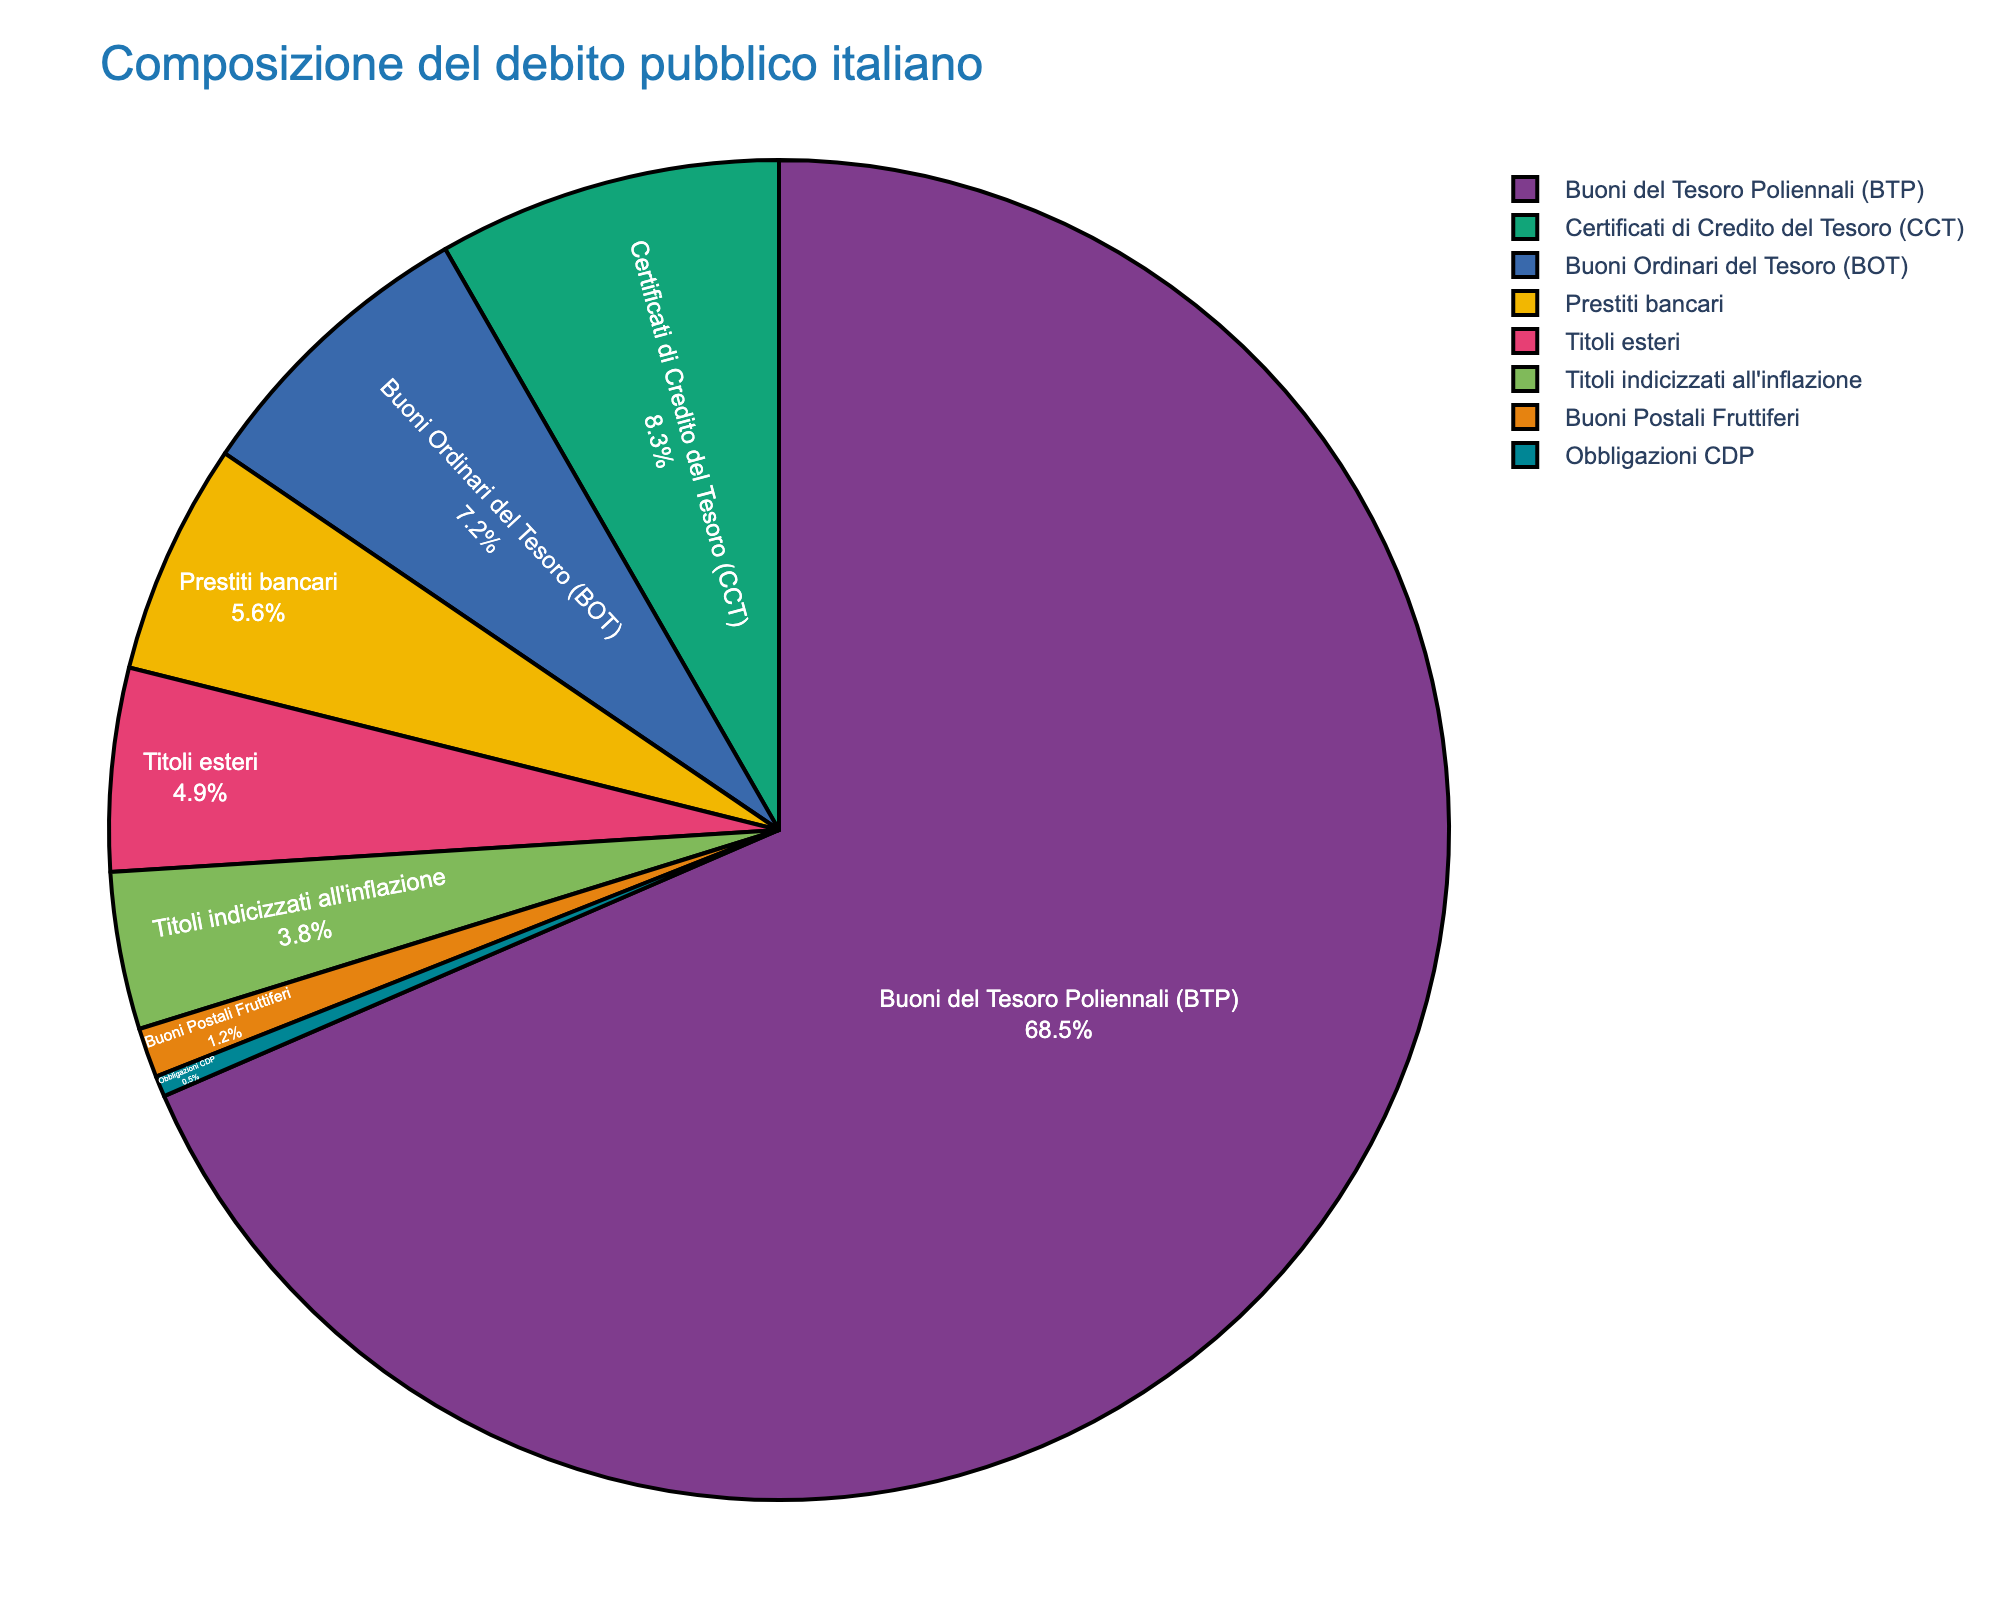What is the financial instrument that constitutes the largest percentage of the Italian public debt? The pie chart shows various financial instruments with their corresponding percentages. The largest section of the pie chart belongs to "Buoni del Tesoro Poliennali (BTP)" with 68.5%.
Answer: Buoni del Tesoro Poliennali (BTP) How much more percentage does Buoni del Tesoro Poliennali (BTP) have compared to Buoni Ordinari del Tesoro (BOT)? Buoni del Tesoro Poliennali (BTP) has 68.5%, while Buoni Ordinari del Tesoro (BOT) has 7.2%. The difference is calculated as 68.5% - 7.2% = 61.3%.
Answer: 61.3% What is the combined percentage of Certificati di Credito del Tesoro (CCT) and Prestiti bancari? The pie chart indicates Certificati di Credito del Tesoro (CCT) at 8.3% and Prestiti bancari at 5.6%. The sum is 8.3% + 5.6% = 13.9%.
Answer: 13.9% Which financial instruments have percentages that are less than 5%? The financial instruments with percentages less than 5% are Titoli esteri with 4.9%, Titoli indicizzati all'inflazione with 3.8%, Buoni Postali Fruttiferi with 1.2%, and Obbligazioni CDP with 0.5%.
Answer: Titoli esteri, Titoli indicizzati all'inflazione, Buoni Postali Fruttiferi, Obbligazioni CDP What is the average percentage of Buoni Ordinari del Tesoro (BOT), Certificati di Credito del Tesoro (CCT), and Prestiti bancari? The percentages for Buoni Ordinari del Tesoro (BOT), Certificati di Credito del Tesoro (CCT), and Prestiti bancari are 7.2%, 8.3%, and 5.6%, respectively. The average is calculated as (7.2 + 8.3 + 5.6) / 3 ≈ 7.03%.
Answer: 7.03% Arrange the financial instruments in descending order based on their percentages. Examining the pie chart, the order is as follows: Buoni del Tesoro Poliennali (BTP) 68.5%, Certificati di Credito del Tesoro (CCT) 8.3%, Buoni Ordinari del Tesoro (BOT) 7.2%, Prestiti bancari 5.6%, Titoli esteri 4.9%, Titoli indicizzati all'inflazione 3.8%, Buoni Postali Fruttiferi 1.2%, Obbligazioni CDP 0.5%.
Answer: Buoni del Tesoro Poliennali (BTP), Certificati di Credito del Tesoro (CCT), Buoni Ordinari del Tesoro (BOT), Prestiti bancari, Titoli esteri, Titoli indicizzati all'inflazione, Buoni Postali Fruttiferi, Obbligazioni CDP What is the total percentage of the financial instruments categorized as Buoni del Tesoro (BTP and BOT)? The pie chart shows Buoni del Tesoro Poliennali (BTP) at 68.5% and Buoni Ordinari del Tesoro (BOT) at 7.2%. The total percentage is 68.5% + 7.2% = 75.7%.
Answer: 75.7% Compare the percentage of Buoni Postali Fruttiferi to Obbligazioni CDP. Which one is larger and by how much? Buoni Postali Fruttiferi has 1.2%, while Obbligazioni CDP has 0.5%. The difference is calculated as 1.2% - 0.5% = 0.7%, and Buoni Postali Fruttiferi is larger.
Answer: Buoni Postali Fruttiferi, 0.7% What are the visual characteristics of the section representing Titoli esteri? The section representing Titoli esteri is colored a distinct color, occupies 4.9% of the pie chart, and is labeled accordingly inside the pie section.
Answer: 4.9% 